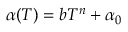<formula> <loc_0><loc_0><loc_500><loc_500>\alpha ( T ) = b T ^ { n } + \alpha _ { 0 }</formula> 